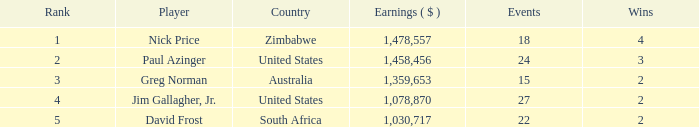How many incidents are in south africa? 22.0. 